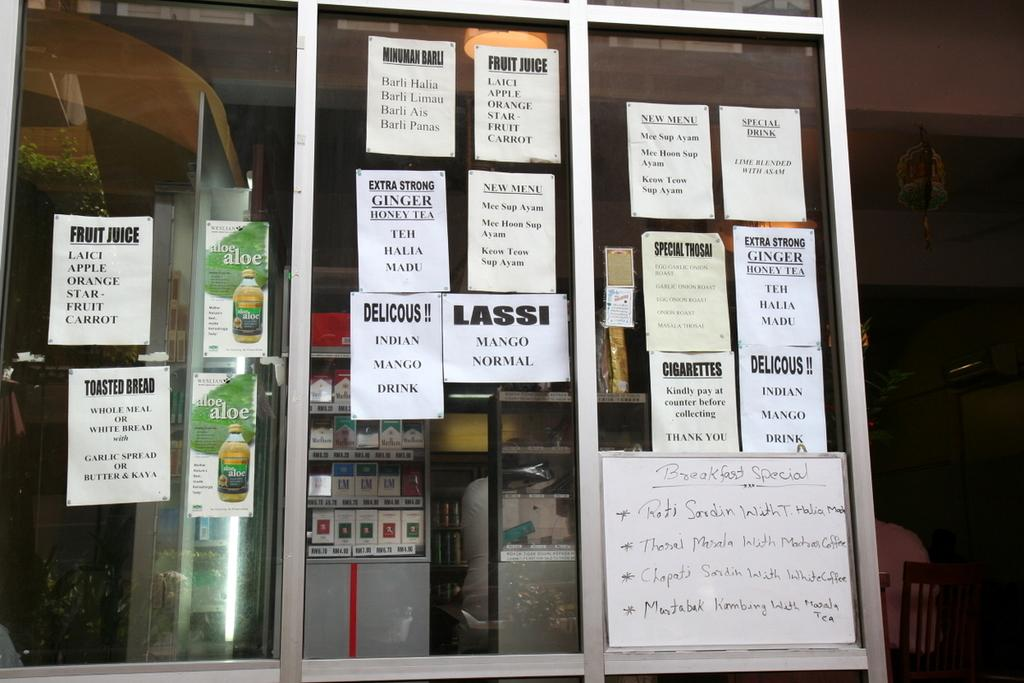<image>
Share a concise interpretation of the image provided. A paper sign says that this place has both normal and mango lassi 